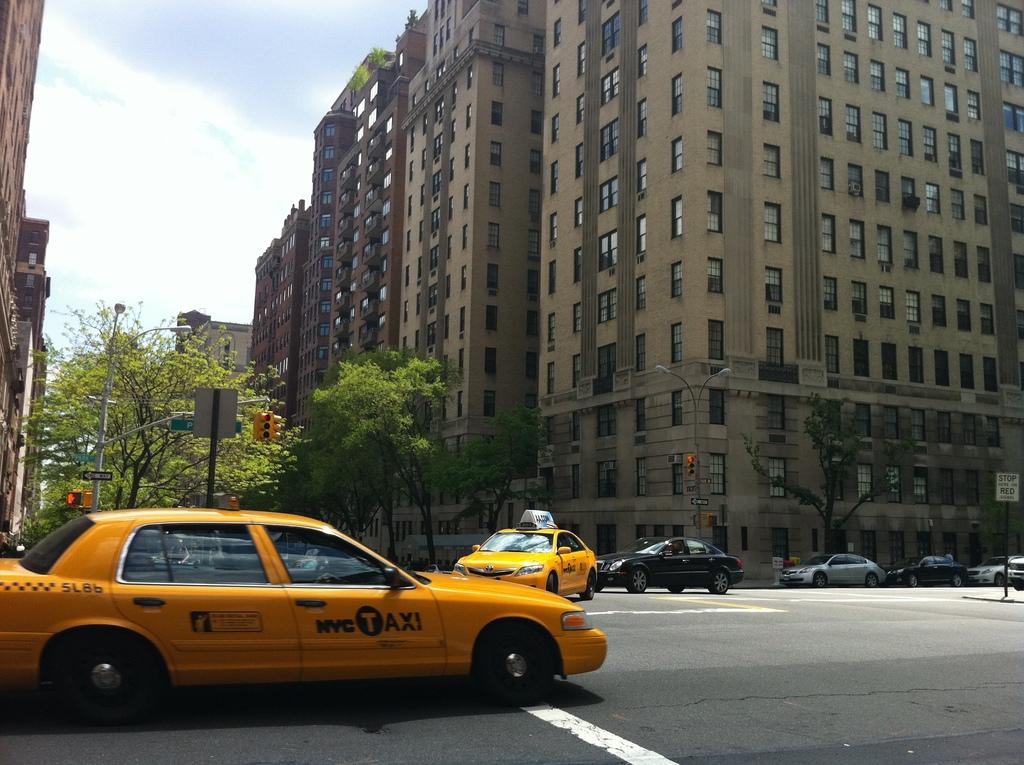Is that a nyc taxi?
Provide a succinct answer. Yes. What is the number on the back of the yellow taxi?
Your response must be concise. 5l86. 